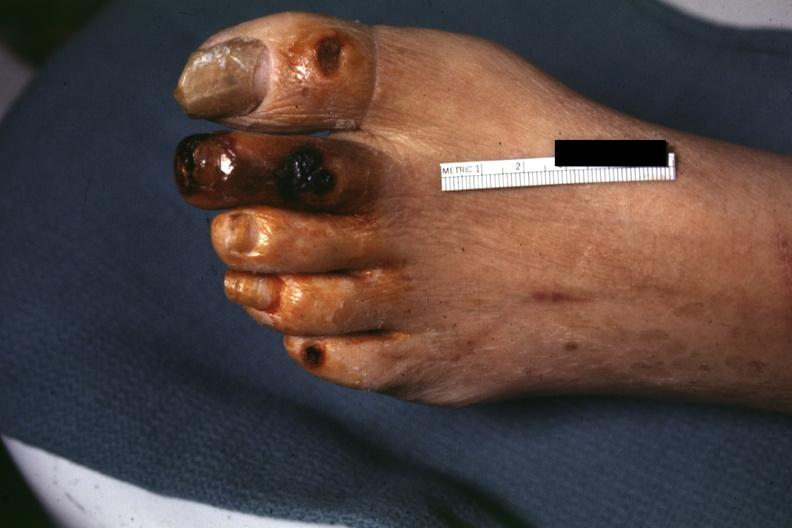re extremities present?
Answer the question using a single word or phrase. Yes 